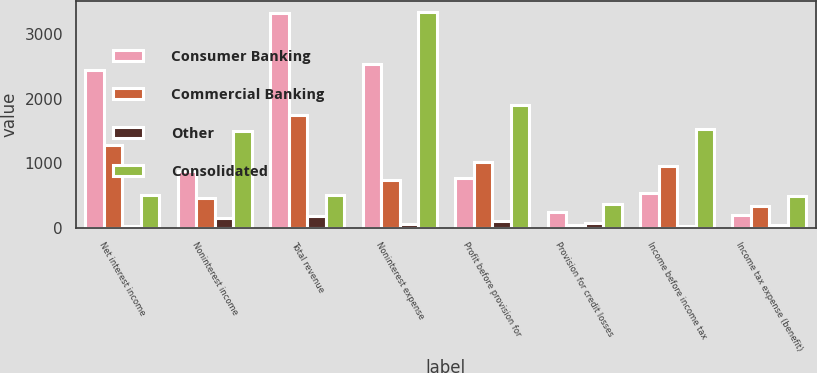<chart> <loc_0><loc_0><loc_500><loc_500><stacked_bar_chart><ecel><fcel>Net interest income<fcel>Noninterest income<fcel>Total revenue<fcel>Noninterest expense<fcel>Profit before provision for<fcel>Provision for credit losses<fcel>Income before income tax<fcel>Income tax expense (benefit)<nl><fcel>Consumer Banking<fcel>2443<fcel>883<fcel>3326<fcel>2547<fcel>779<fcel>243<fcel>536<fcel>191<nl><fcel>Commercial Banking<fcel>1288<fcel>466<fcel>1754<fcel>741<fcel>1013<fcel>47<fcel>966<fcel>335<nl><fcel>Other<fcel>27<fcel>148<fcel>175<fcel>64<fcel>111<fcel>79<fcel>32<fcel>37<nl><fcel>Consolidated<fcel>512.5<fcel>1497<fcel>512.5<fcel>3352<fcel>1903<fcel>369<fcel>1534<fcel>489<nl></chart> 